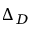Convert formula to latex. <formula><loc_0><loc_0><loc_500><loc_500>\Delta _ { D }</formula> 